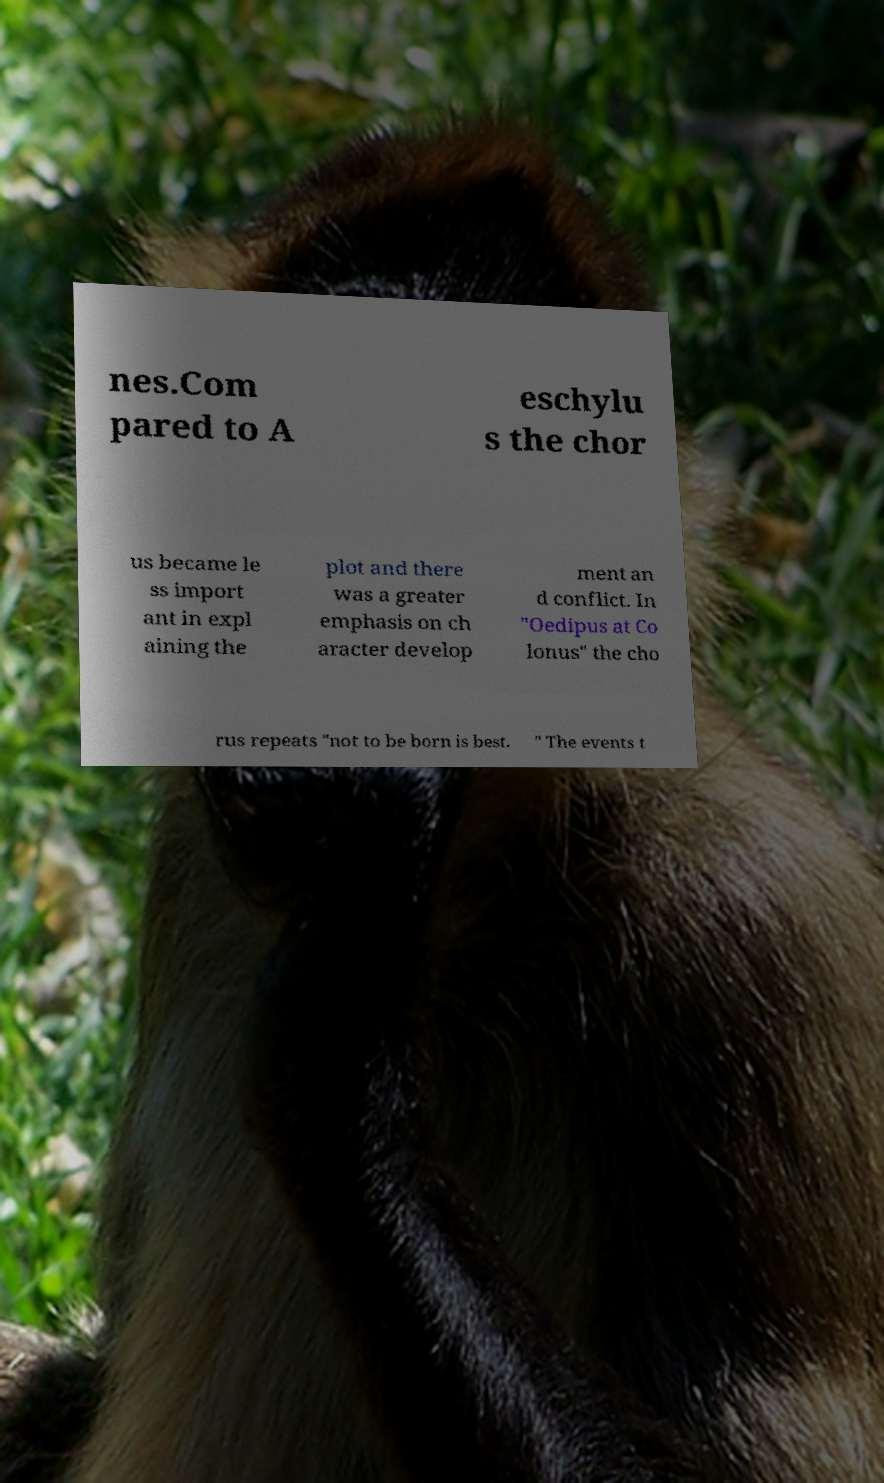Can you accurately transcribe the text from the provided image for me? nes.Com pared to A eschylu s the chor us became le ss import ant in expl aining the plot and there was a greater emphasis on ch aracter develop ment an d conflict. In "Oedipus at Co lonus" the cho rus repeats "not to be born is best. " The events t 